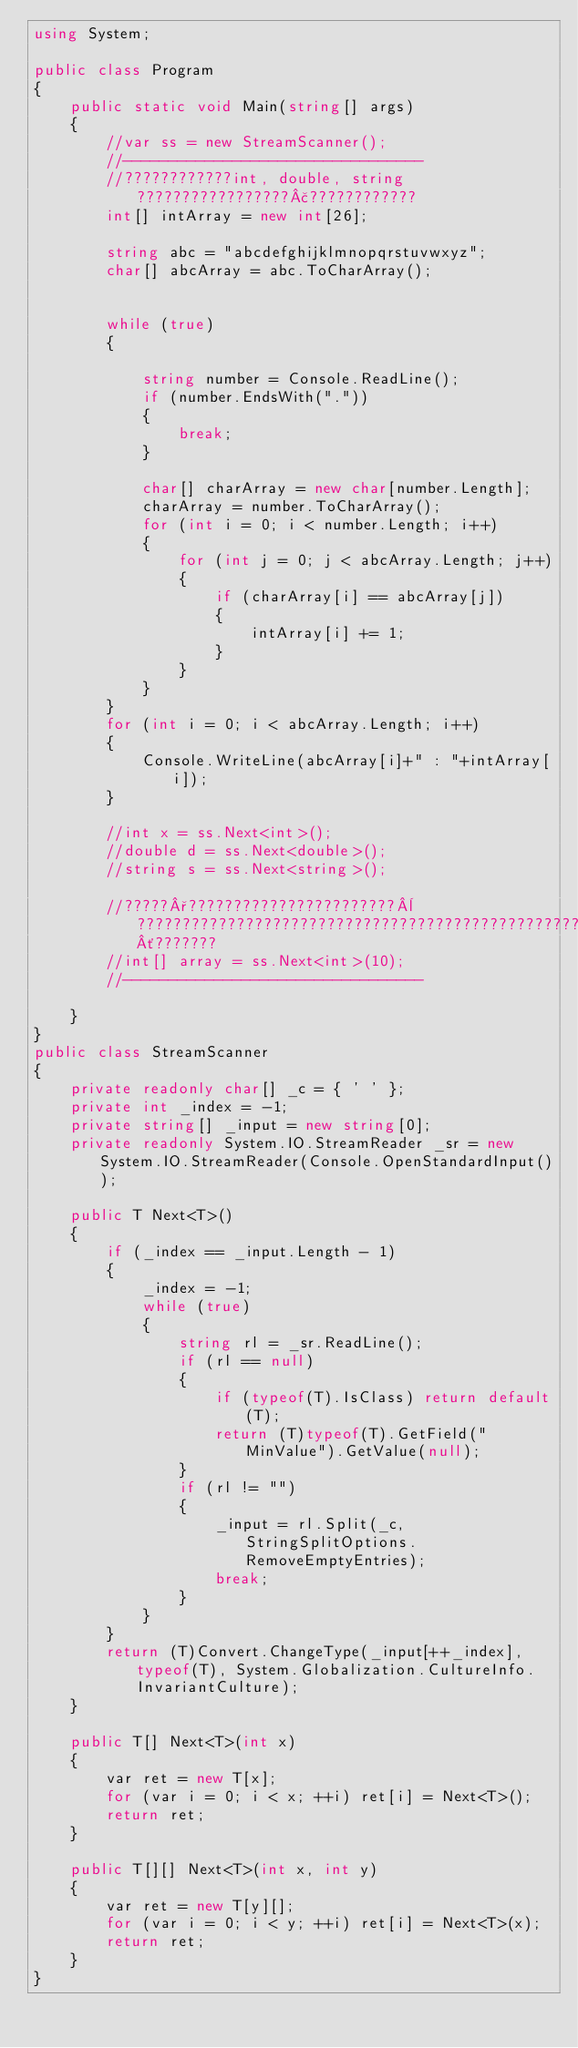Convert code to text. <code><loc_0><loc_0><loc_500><loc_500><_C#_>using System;

public class Program
{
	public static void Main(string[] args)
	{
		//var ss = new StreamScanner();
		//---------------------------------
		//????????????int, double, string?????????????????£????????????
		int[] intArray = new int[26];

		string abc = "abcdefghijklmnopqrstuvwxyz";
		char[] abcArray = abc.ToCharArray();


		while (true)
		{

			string number = Console.ReadLine();
			if (number.EndsWith("."))
			{
				break;
			}

			char[] charArray = new char[number.Length];
			charArray = number.ToCharArray();
			for (int i = 0; i < number.Length; i++)
			{
				for (int j = 0; j < abcArray.Length; j++)
				{
					if (charArray[i] == abcArray[j])
					{
						intArray[i] += 1;
					}
				}
			}
		}
		for (int i = 0; i < abcArray.Length; i++)
		{
			Console.WriteLine(abcArray[i]+" : "+intArray[i]);
		}

		//int x = ss.Next<int>();
		//double d = ss.Next<double>();
		//string s = ss.Next<string>();

		//?????°???????????????????????¨?????????????????????????????????????????????????´???????
		//int[] array = ss.Next<int>(10);
		//---------------------------------

	}
}
public class StreamScanner
{
	private readonly char[] _c = { ' ' };
	private int _index = -1;
	private string[] _input = new string[0];
	private readonly System.IO.StreamReader _sr = new System.IO.StreamReader(Console.OpenStandardInput());

	public T Next<T>()
	{
		if (_index == _input.Length - 1)
		{
			_index = -1;
			while (true)
			{
				string rl = _sr.ReadLine();
				if (rl == null)
				{
					if (typeof(T).IsClass) return default(T);
					return (T)typeof(T).GetField("MinValue").GetValue(null);
				}
				if (rl != "")
				{
					_input = rl.Split(_c, StringSplitOptions.RemoveEmptyEntries);
					break;
				}
			}
		}
		return (T)Convert.ChangeType(_input[++_index], typeof(T), System.Globalization.CultureInfo.InvariantCulture);
	}

	public T[] Next<T>(int x)
	{
		var ret = new T[x];
		for (var i = 0; i < x; ++i) ret[i] = Next<T>();
		return ret;
	}

	public T[][] Next<T>(int x, int y)
	{
		var ret = new T[y][];
		for (var i = 0; i < y; ++i) ret[i] = Next<T>(x);
		return ret;
	}
}</code> 